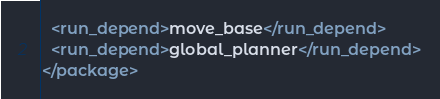Convert code to text. <code><loc_0><loc_0><loc_500><loc_500><_XML_>  <run_depend>move_base</run_depend>
  <run_depend>global_planner</run_depend>
</package>
</code> 